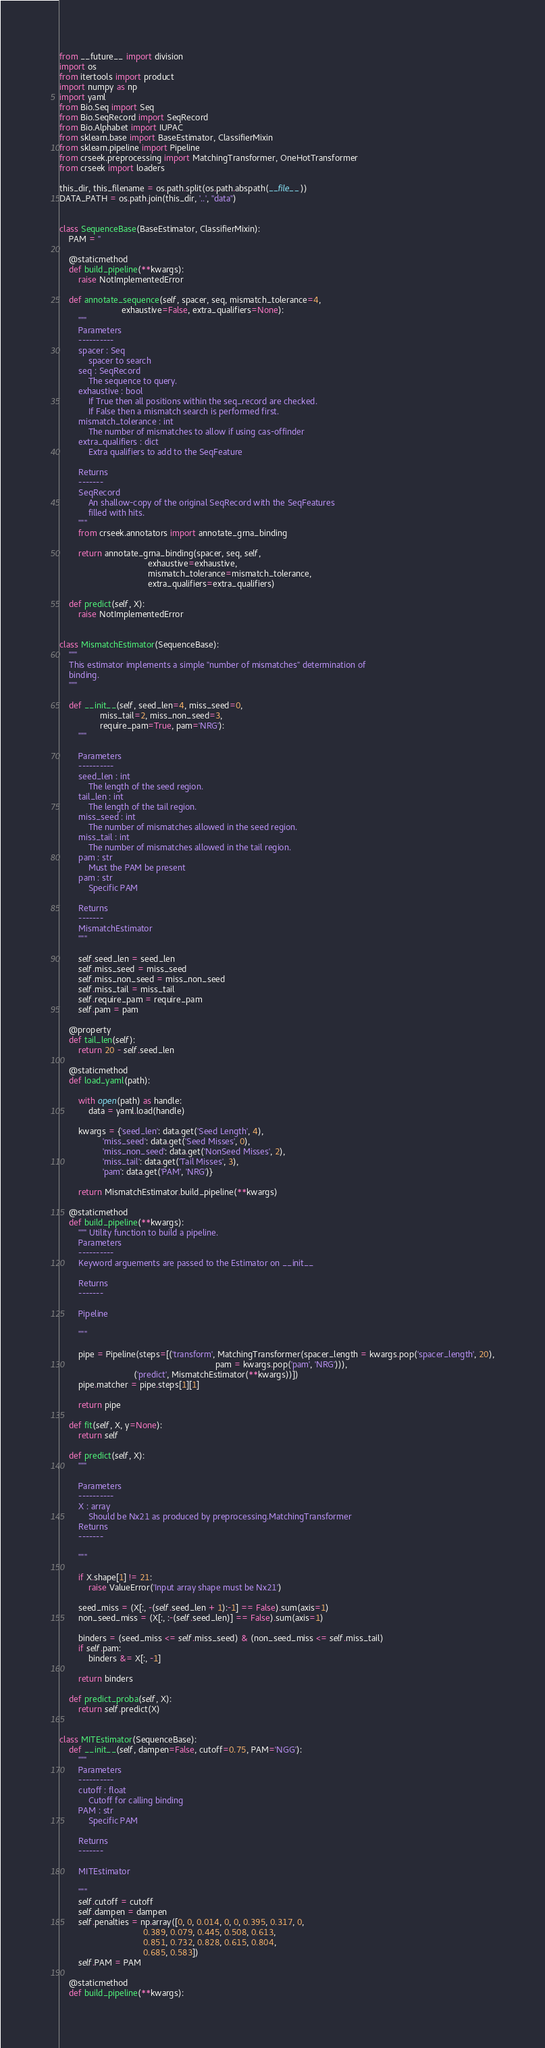Convert code to text. <code><loc_0><loc_0><loc_500><loc_500><_Python_>from __future__ import division
import os
from itertools import product
import numpy as np
import yaml
from Bio.Seq import Seq
from Bio.SeqRecord import SeqRecord
from Bio.Alphabet import IUPAC
from sklearn.base import BaseEstimator, ClassifierMixin
from sklearn.pipeline import Pipeline
from crseek.preprocessing import MatchingTransformer, OneHotTransformer
from crseek import loaders

this_dir, this_filename = os.path.split(os.path.abspath(__file__))
DATA_PATH = os.path.join(this_dir, '..', "data")


class SequenceBase(BaseEstimator, ClassifierMixin):
    PAM = ''

    @staticmethod
    def build_pipeline(**kwargs):
        raise NotImplementedError

    def annotate_sequence(self, spacer, seq, mismatch_tolerance=4,
                          exhaustive=False, extra_qualifiers=None):
        """
        Parameters
        ----------
        spacer : Seq
            spacer to search
        seq : SeqRecord
            The sequence to query.
        exhaustive : bool
            If True then all positions within the seq_record are checked.
            If False then a mismatch search is performed first.
        mismatch_tolerance : int
            The number of mismatches to allow if using cas-offinder
        extra_qualifiers : dict
            Extra qualifiers to add to the SeqFeature

        Returns
        -------
        SeqRecord
            An shallow-copy of the original SeqRecord with the SeqFeatures
            filled with hits.
        """
        from crseek.annotators import annotate_grna_binding

        return annotate_grna_binding(spacer, seq, self,
                                     exhaustive=exhaustive,
                                     mismatch_tolerance=mismatch_tolerance,
                                     extra_qualifiers=extra_qualifiers)

    def predict(self, X):
        raise NotImplementedError


class MismatchEstimator(SequenceBase):
    """
    This estimator implements a simple "number of mismatches" determination of
    binding.
    """

    def __init__(self, seed_len=4, miss_seed=0,
                 miss_tail=2, miss_non_seed=3,
                 require_pam=True, pam='NRG'):
        """

        Parameters
        ----------
        seed_len : int
            The length of the seed region.
        tail_len : int
            The length of the tail region.
        miss_seed : int
            The number of mismatches allowed in the seed region.
        miss_tail : int
            The number of mismatches allowed in the tail region.
        pam : str
            Must the PAM be present
        pam : str
            Specific PAM

        Returns
        -------
        MismatchEstimator
        """

        self.seed_len = seed_len
        self.miss_seed = miss_seed
        self.miss_non_seed = miss_non_seed
        self.miss_tail = miss_tail
        self.require_pam = require_pam
        self.pam = pam

    @property
    def tail_len(self):
        return 20 - self.seed_len

    @staticmethod
    def load_yaml(path):

        with open(path) as handle:
            data = yaml.load(handle)

        kwargs = {'seed_len': data.get('Seed Length', 4),
                  'miss_seed': data.get('Seed Misses', 0),
                  'miss_non_seed': data.get('NonSeed Misses', 2),
                  'miss_tail': data.get('Tail Misses', 3),
                  'pam': data.get('PAM', 'NRG')}

        return MismatchEstimator.build_pipeline(**kwargs)

    @staticmethod
    def build_pipeline(**kwargs):
        """ Utility function to build a pipeline.
        Parameters
        ----------
        Keyword arguements are passed to the Estimator on __init__

        Returns
        -------

        Pipeline

        """

        pipe = Pipeline(steps=[('transform', MatchingTransformer(spacer_length = kwargs.pop('spacer_length', 20),
                                                                 pam = kwargs.pop('pam', 'NRG'))),
                               ('predict', MismatchEstimator(**kwargs))])
        pipe.matcher = pipe.steps[1][1]

        return pipe

    def fit(self, X, y=None):
        return self

    def predict(self, X):
        """

        Parameters
        ----------
        X : array
            Should be Nx21 as produced by preprocessing.MatchingTransformer
        Returns
        -------

        """

        if X.shape[1] != 21:
            raise ValueError('Input array shape must be Nx21')

        seed_miss = (X[:, -(self.seed_len + 1):-1] == False).sum(axis=1)
        non_seed_miss = (X[:, :-(self.seed_len)] == False).sum(axis=1)

        binders = (seed_miss <= self.miss_seed) & (non_seed_miss <= self.miss_tail)
        if self.pam:
            binders &= X[:, -1]

        return binders

    def predict_proba(self, X):
        return self.predict(X)


class MITEstimator(SequenceBase):
    def __init__(self, dampen=False, cutoff=0.75, PAM='NGG'):
        """
        Parameters
        ----------
        cutoff : float
            Cutoff for calling binding
        PAM : str
            Specific PAM

        Returns
        -------

        MITEstimator

        """
        self.cutoff = cutoff
        self.dampen = dampen
        self.penalties = np.array([0, 0, 0.014, 0, 0, 0.395, 0.317, 0,
                                   0.389, 0.079, 0.445, 0.508, 0.613,
                                   0.851, 0.732, 0.828, 0.615, 0.804,
                                   0.685, 0.583])
        self.PAM = PAM

    @staticmethod
    def build_pipeline(**kwargs):</code> 